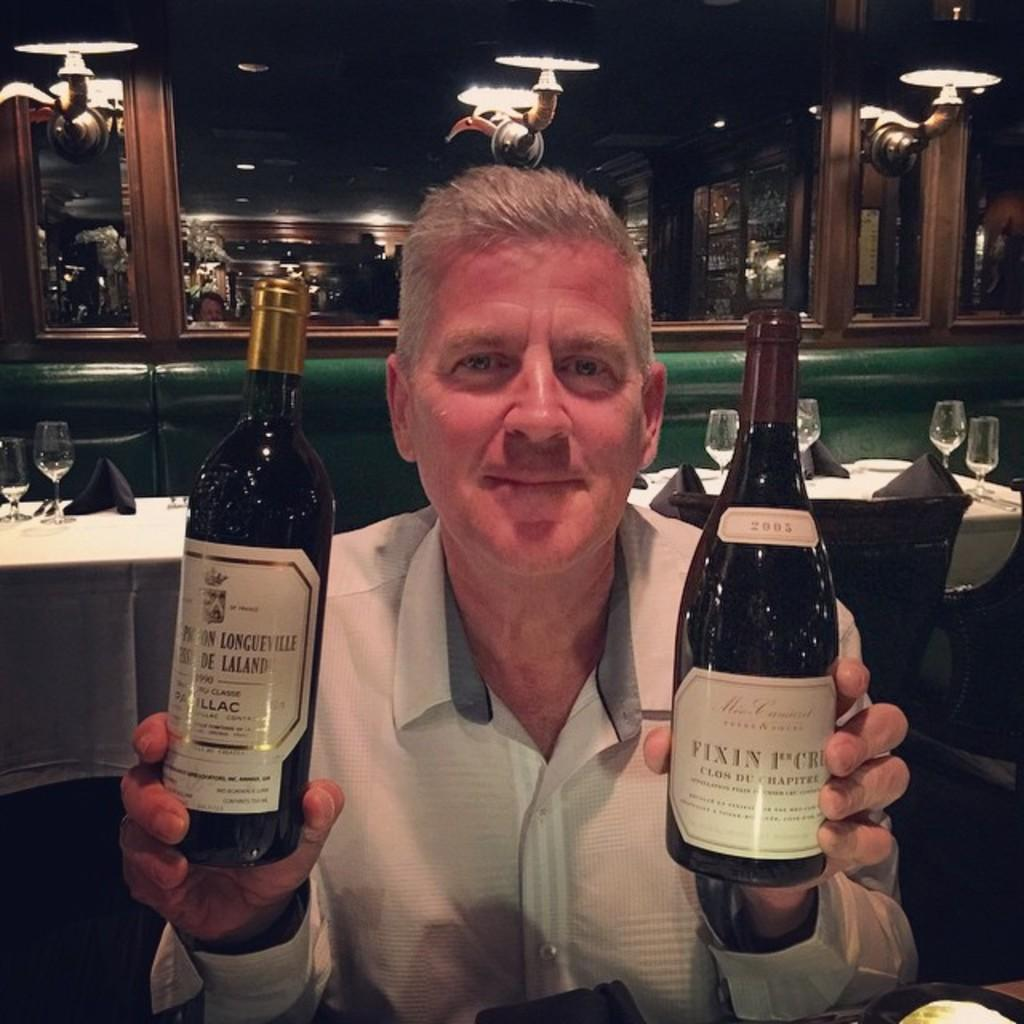<image>
Write a terse but informative summary of the picture. a man that is holding a bottle that says fixin 